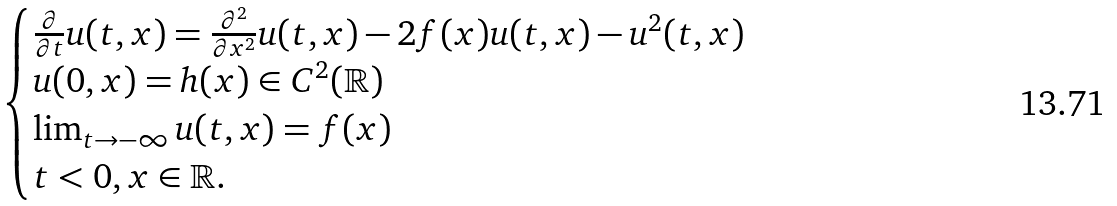<formula> <loc_0><loc_0><loc_500><loc_500>\begin{cases} \frac { \partial } { \partial t } u ( t , x ) = \frac { \partial ^ { 2 } } { \partial x ^ { 2 } } u ( t , x ) - 2 f ( x ) u ( t , x ) - u ^ { 2 } ( t , x ) \\ u ( 0 , x ) = h ( x ) \in C ^ { 2 } ( \mathbb { R } ) \\ \lim _ { t \to - \infty } u ( t , x ) = f ( x ) \\ t < 0 , x \in \mathbb { R } . \\ \end{cases}</formula> 